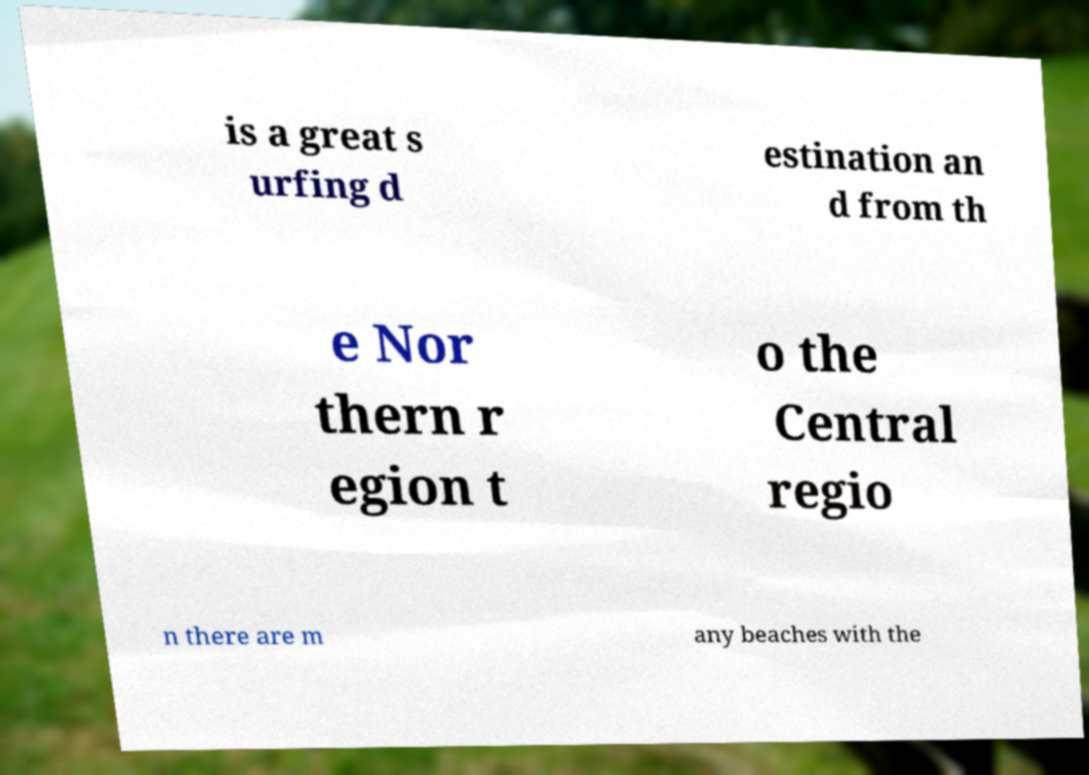Can you accurately transcribe the text from the provided image for me? is a great s urfing d estination an d from th e Nor thern r egion t o the Central regio n there are m any beaches with the 